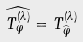<formula> <loc_0><loc_0><loc_500><loc_500>\widehat { T _ { \varphi } ^ { ( \lambda ) } } = T ^ { ( \lambda ) } _ { \widehat { \varphi } }</formula> 